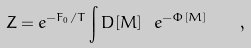<formula> <loc_0><loc_0><loc_500><loc_500>Z = e ^ { - F _ { 0 } / T } \int D [ { M } ] \ e ^ { - \Phi [ { M } ] } \quad ,</formula> 